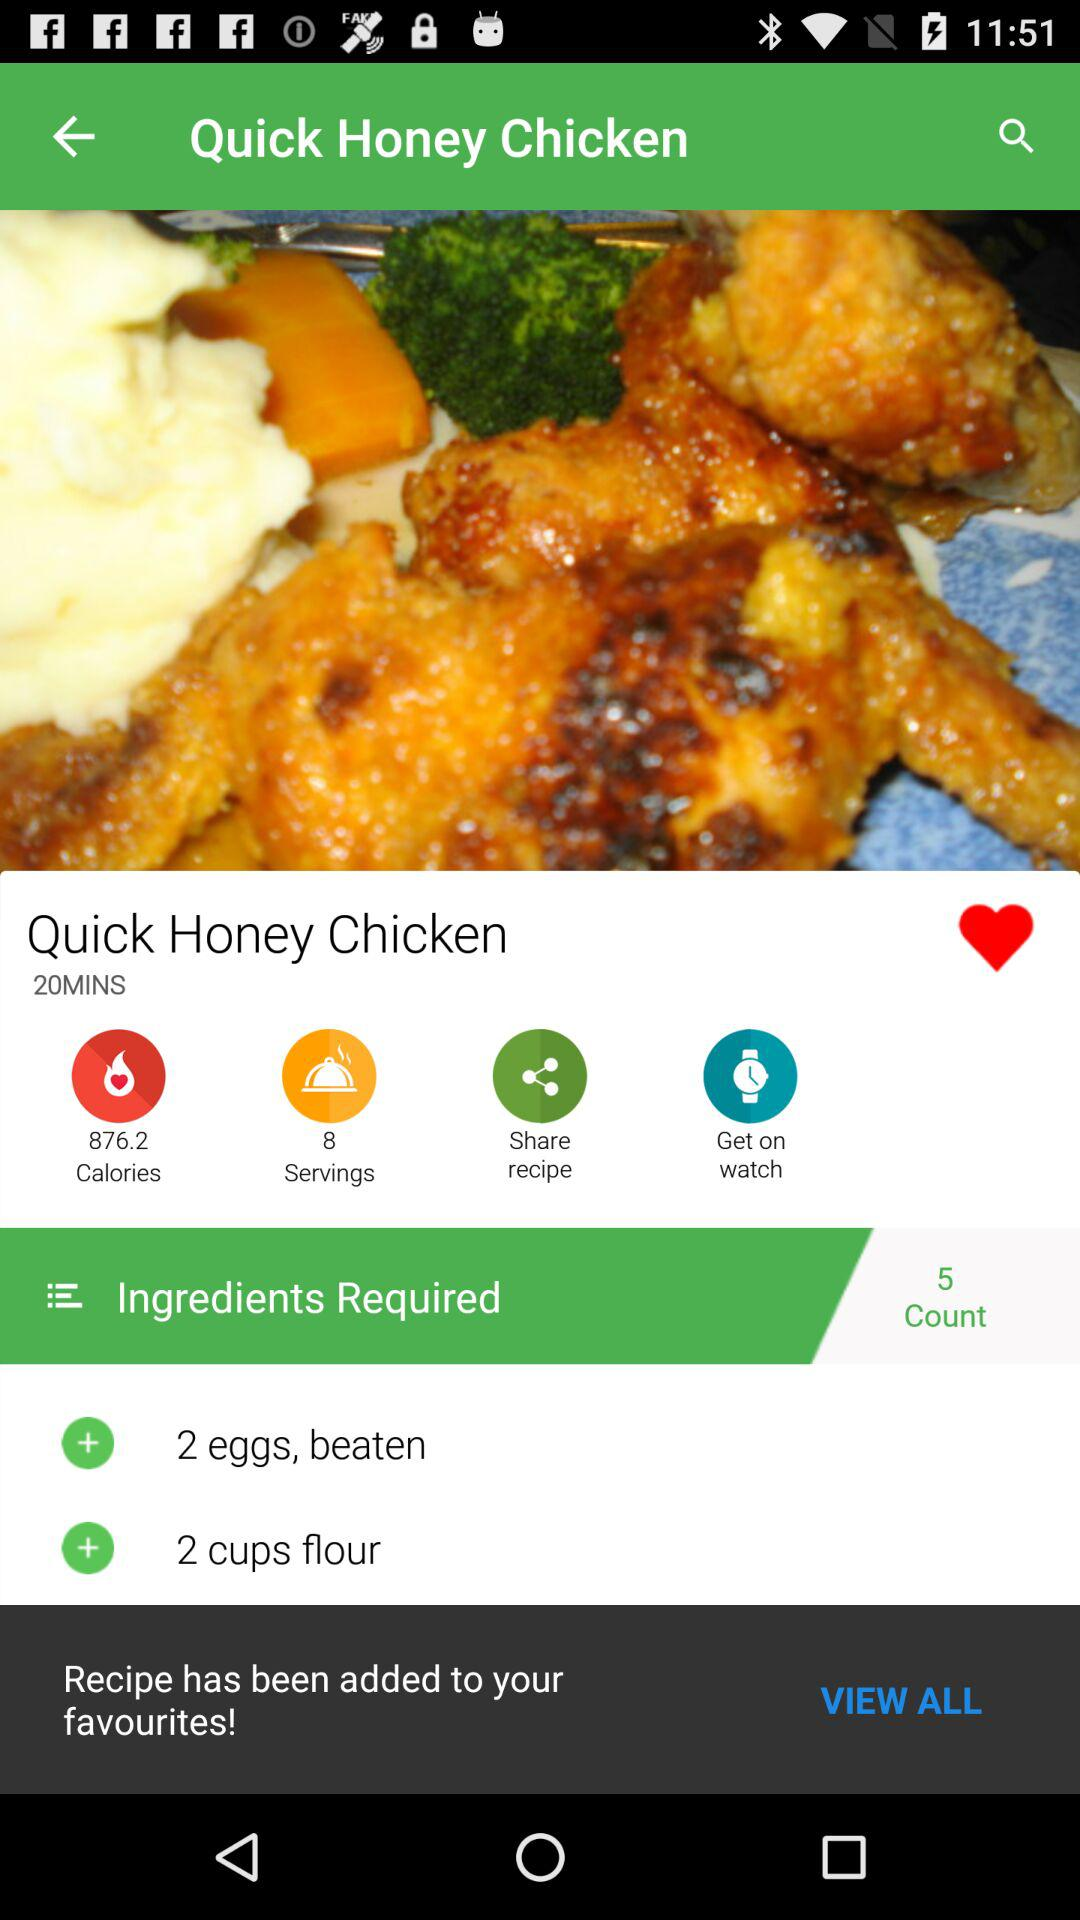How many calories are in the recipe?
Answer the question using a single word or phrase. 876.2 